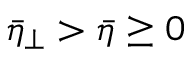Convert formula to latex. <formula><loc_0><loc_0><loc_500><loc_500>\bar { \eta } _ { \perp } > \bar { \eta } \geq 0</formula> 